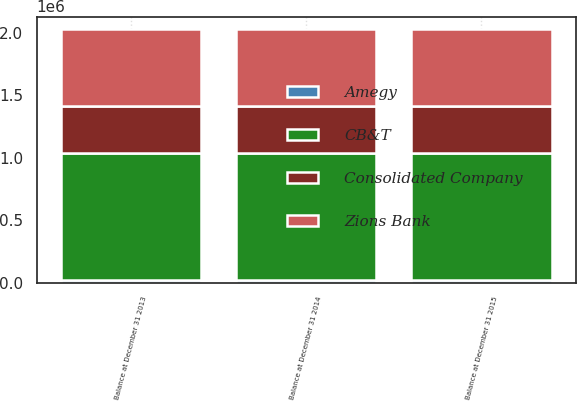Convert chart. <chart><loc_0><loc_0><loc_500><loc_500><stacked_bar_chart><ecel><fcel>Balance at December 31 2013<fcel>Balance at December 31 2014<fcel>Balance at December 31 2015<nl><fcel>Amegy<fcel>19514<fcel>19514<fcel>19514<nl><fcel>Consolidated Company<fcel>379024<fcel>379024<fcel>379024<nl><fcel>Zions Bank<fcel>615591<fcel>615591<fcel>615591<nl><fcel>CB&T<fcel>1.01413e+06<fcel>1.01413e+06<fcel>1.01413e+06<nl></chart> 